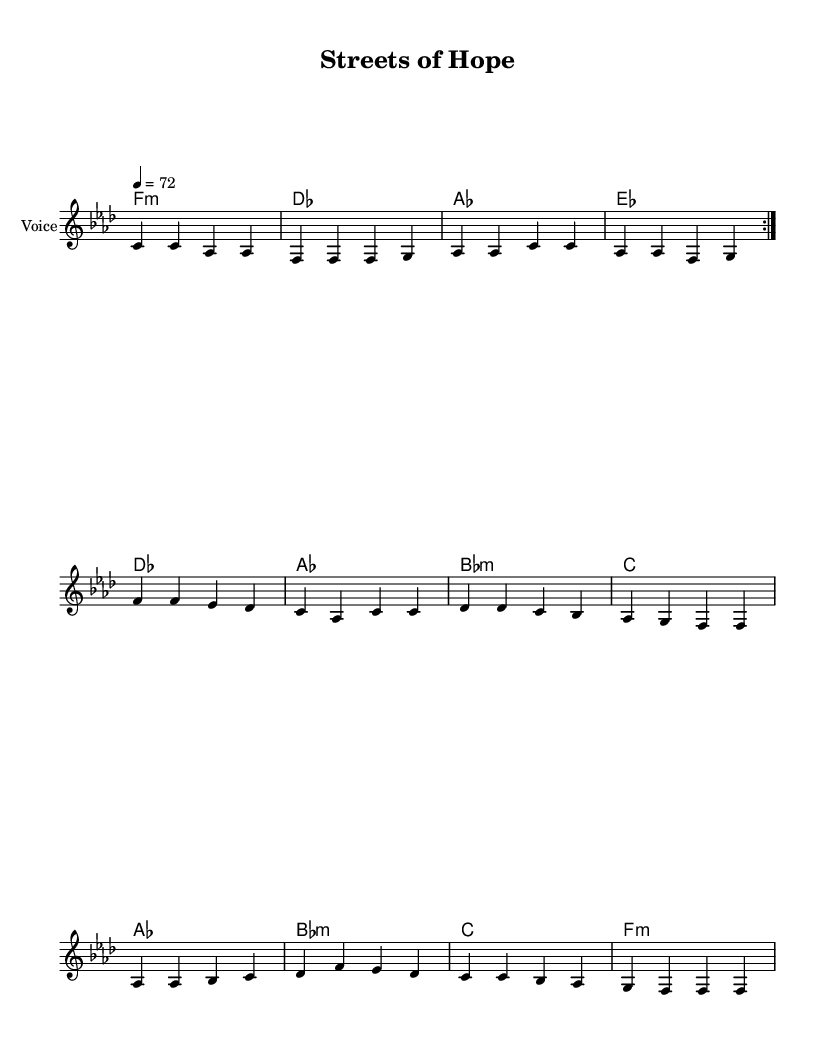What is the key signature of this music? The key signature is indicated by the accidentals shown at the beginning of the staff. Here, there are four flats, which corresponds to the key of F minor.
Answer: F minor What is the time signature of this music? The time signature appears at the beginning of the sheet music after the key signature. In this case, it is 4/4, meaning there are four beats in each measure.
Answer: 4/4 What is the tempo marking of this piece? The tempo marking is displayed clearly at the beginning of the score. It states that the tempo is quarter note equals 72 beats per minute.
Answer: 72 How many measures are repeated in the melody? The score indicates a repeat of the melody section with a 'volta' sign, meaning the section is played twice. Counting the measures leads to a total of two full repetitions.
Answer: 2 What is the main theme expressed in the chorus lyrics? The chorus lyrics highlight community empowerment and addressing urban area issues. These two elements indicate the central theme of socio-political commentary in the music.
Answer: Community empowerment How do the harmonies support the lyrical theme? Each chord progression follows the emotion conveyed in the lyrics. The use of minor chords can invoke a sense of struggle, while major chords may indicate hope and resolution, enhancing the message of positive change in urban contexts.
Answer: Hope and struggle What underlying societal issue does this ballad address? The lyrics discuss themes of inequality and the need for positive change in urban environments, highlighting issues such as social justice and empowerment in communities.
Answer: Inequality 